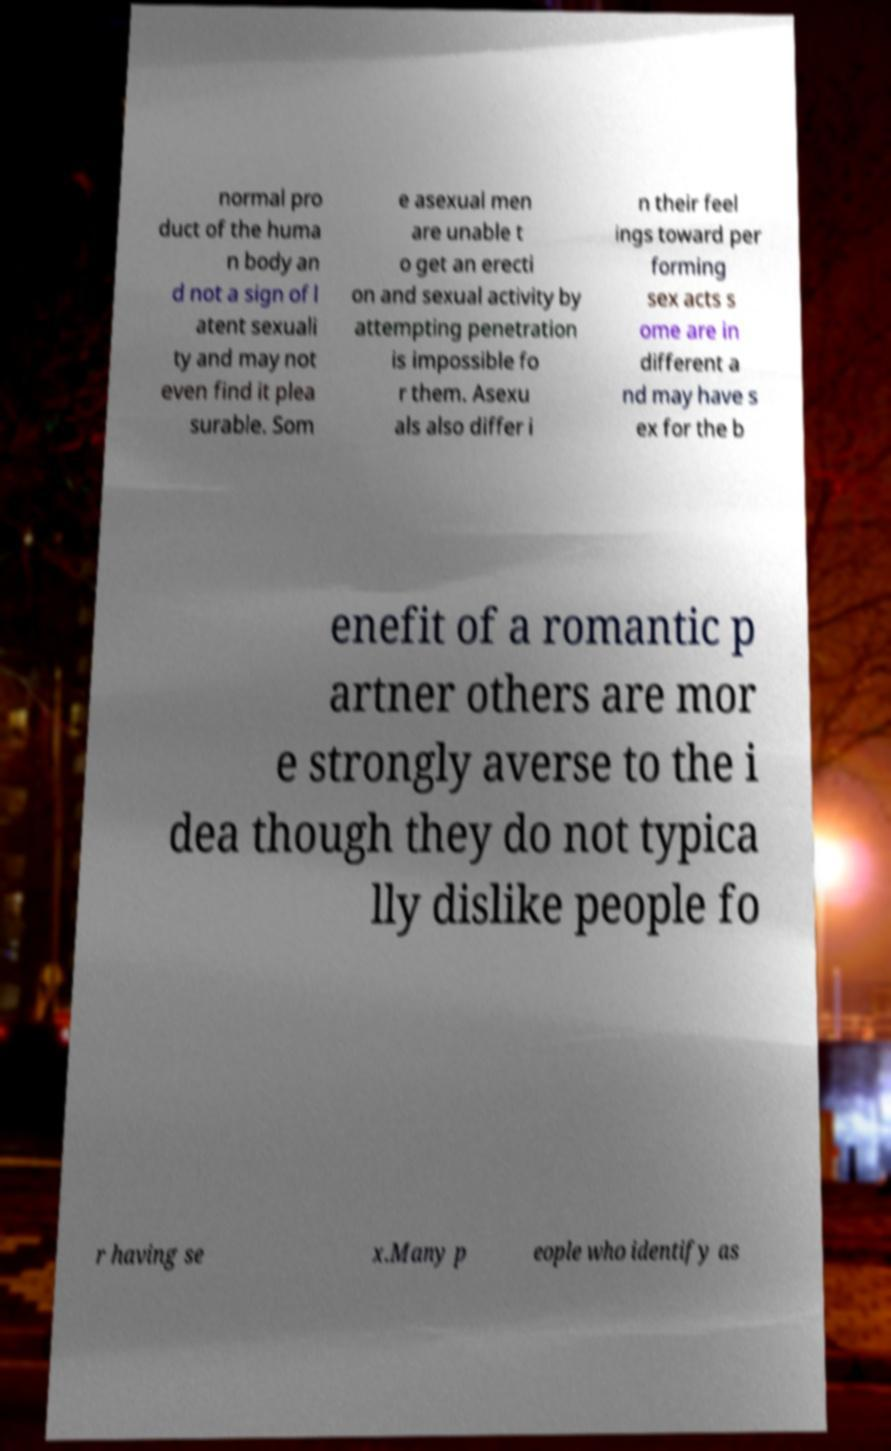Please read and relay the text visible in this image. What does it say? normal pro duct of the huma n body an d not a sign of l atent sexuali ty and may not even find it plea surable. Som e asexual men are unable t o get an erecti on and sexual activity by attempting penetration is impossible fo r them. Asexu als also differ i n their feel ings toward per forming sex acts s ome are in different a nd may have s ex for the b enefit of a romantic p artner others are mor e strongly averse to the i dea though they do not typica lly dislike people fo r having se x.Many p eople who identify as 